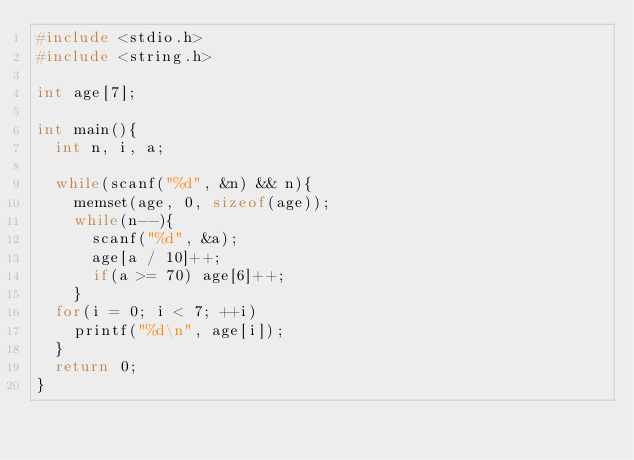Convert code to text. <code><loc_0><loc_0><loc_500><loc_500><_C_>#include <stdio.h>
#include <string.h>

int age[7];

int main(){
  int n, i, a;

  while(scanf("%d", &n) && n){
    memset(age, 0, sizeof(age));
    while(n--){
      scanf("%d", &a);
      age[a / 10]++;
      if(a >= 70) age[6]++;
    }
  for(i = 0; i < 7; ++i)
    printf("%d\n", age[i]);
  }
  return 0;
}</code> 